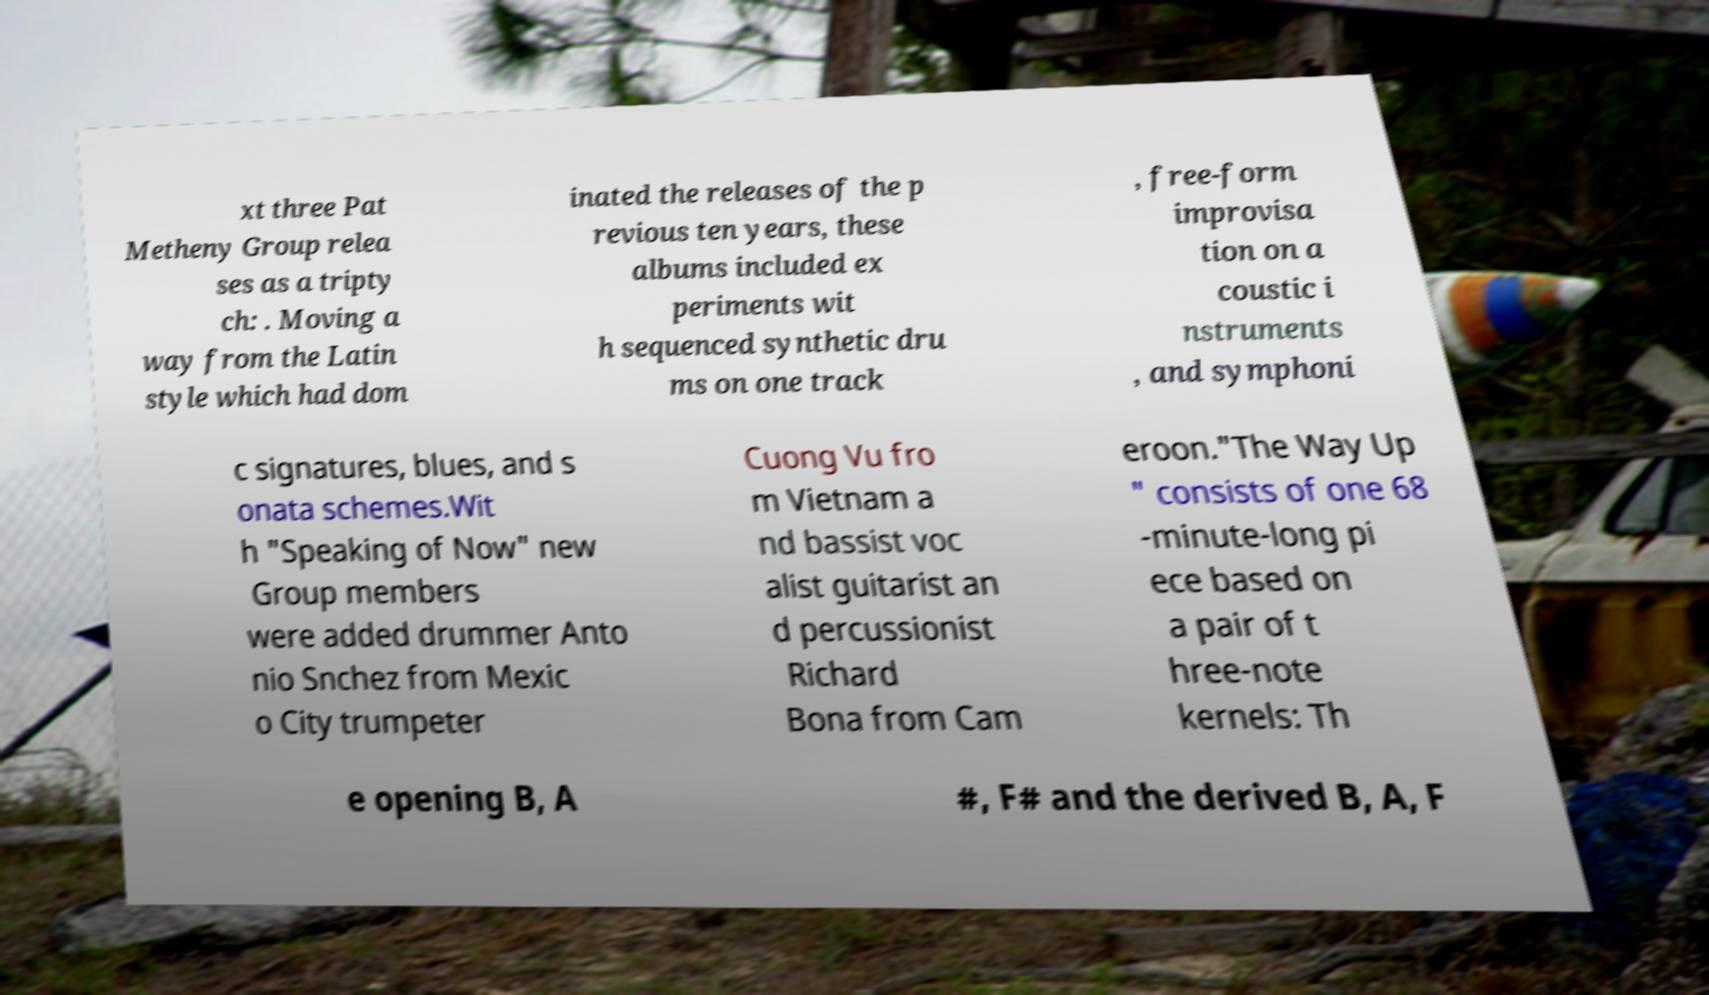Can you accurately transcribe the text from the provided image for me? xt three Pat Metheny Group relea ses as a tripty ch: . Moving a way from the Latin style which had dom inated the releases of the p revious ten years, these albums included ex periments wit h sequenced synthetic dru ms on one track , free-form improvisa tion on a coustic i nstruments , and symphoni c signatures, blues, and s onata schemes.Wit h "Speaking of Now" new Group members were added drummer Anto nio Snchez from Mexic o City trumpeter Cuong Vu fro m Vietnam a nd bassist voc alist guitarist an d percussionist Richard Bona from Cam eroon."The Way Up " consists of one 68 -minute-long pi ece based on a pair of t hree-note kernels: Th e opening B, A #, F# and the derived B, A, F 